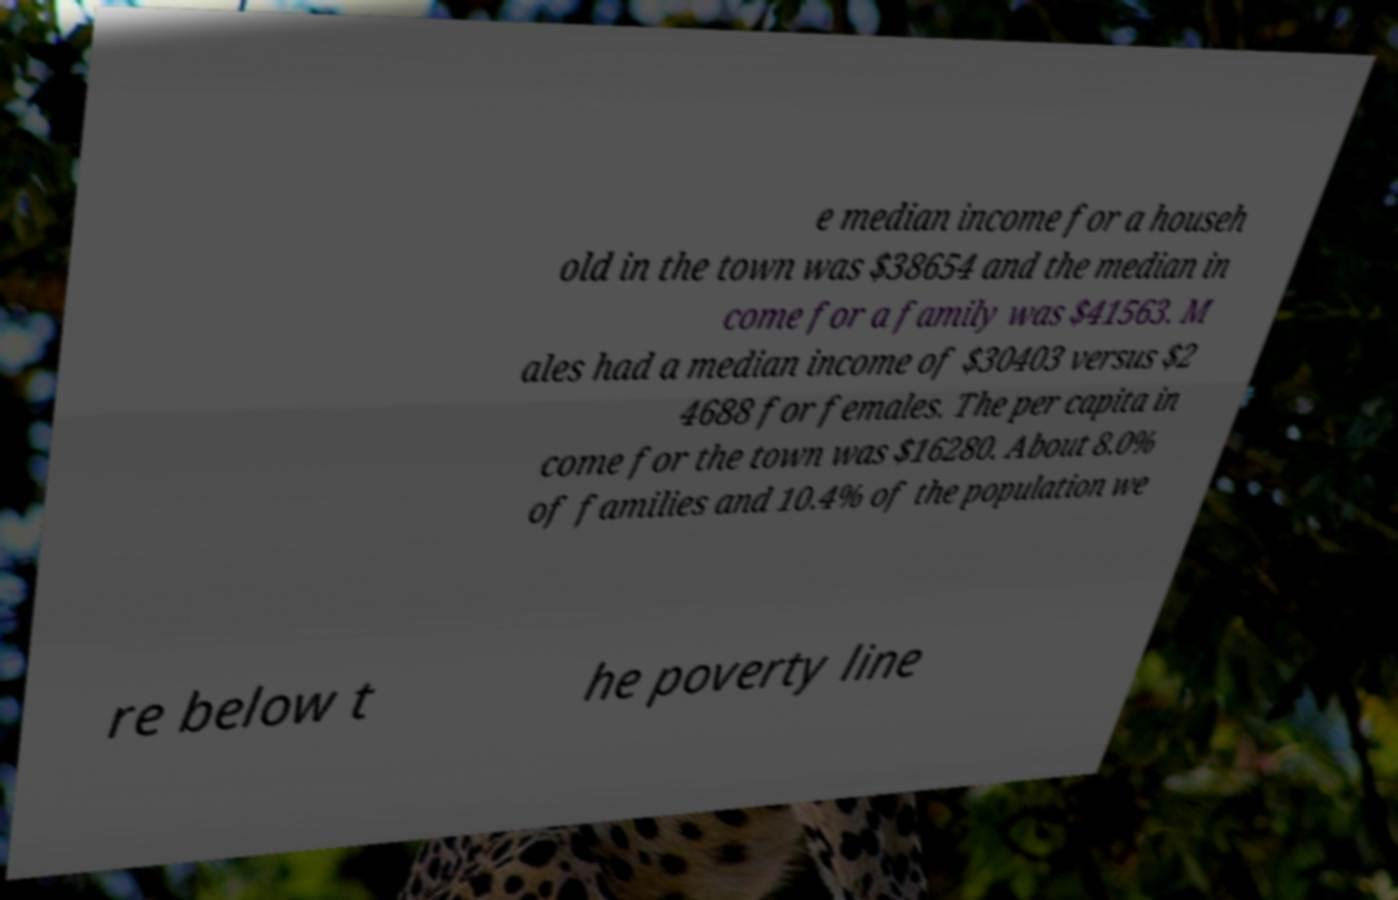There's text embedded in this image that I need extracted. Can you transcribe it verbatim? e median income for a househ old in the town was $38654 and the median in come for a family was $41563. M ales had a median income of $30403 versus $2 4688 for females. The per capita in come for the town was $16280. About 8.0% of families and 10.4% of the population we re below t he poverty line 